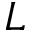<formula> <loc_0><loc_0><loc_500><loc_500>L</formula> 